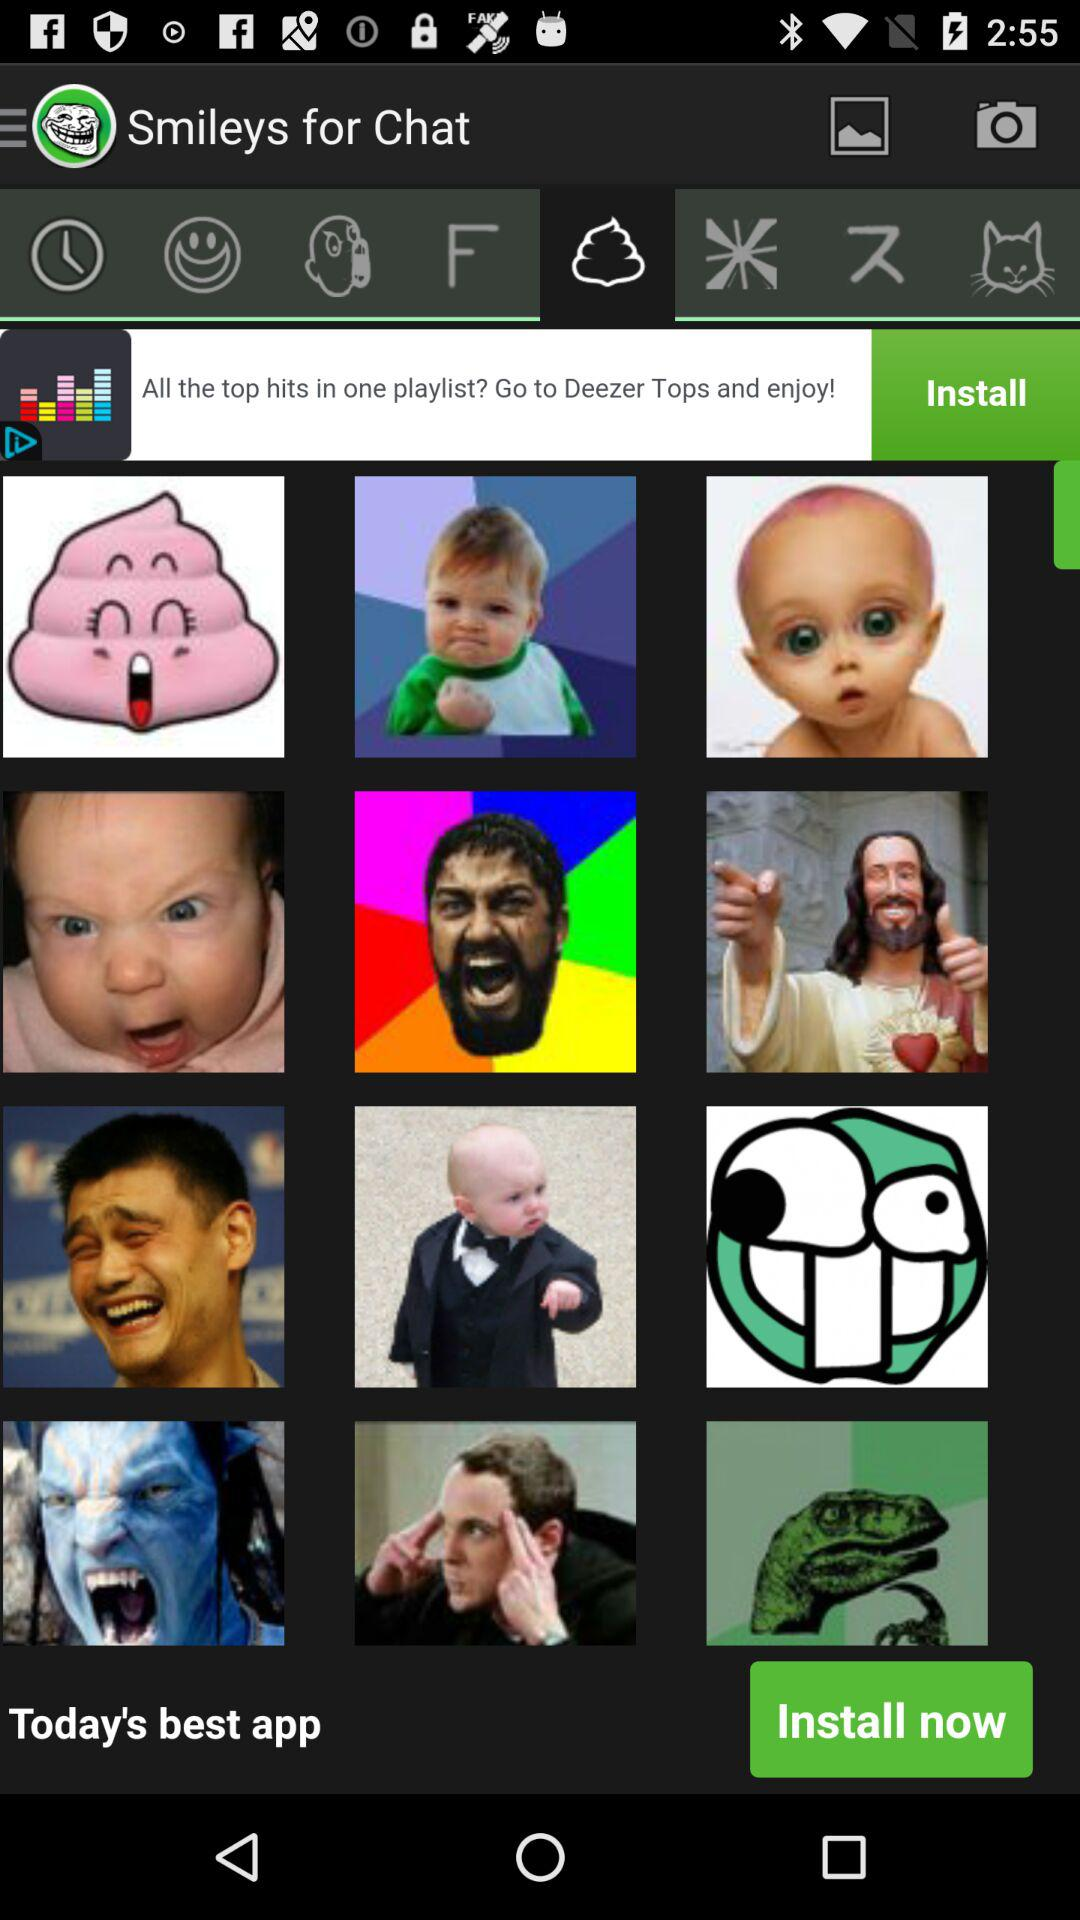What is the name of the application? The name of the application is "Smileys for Chat". 